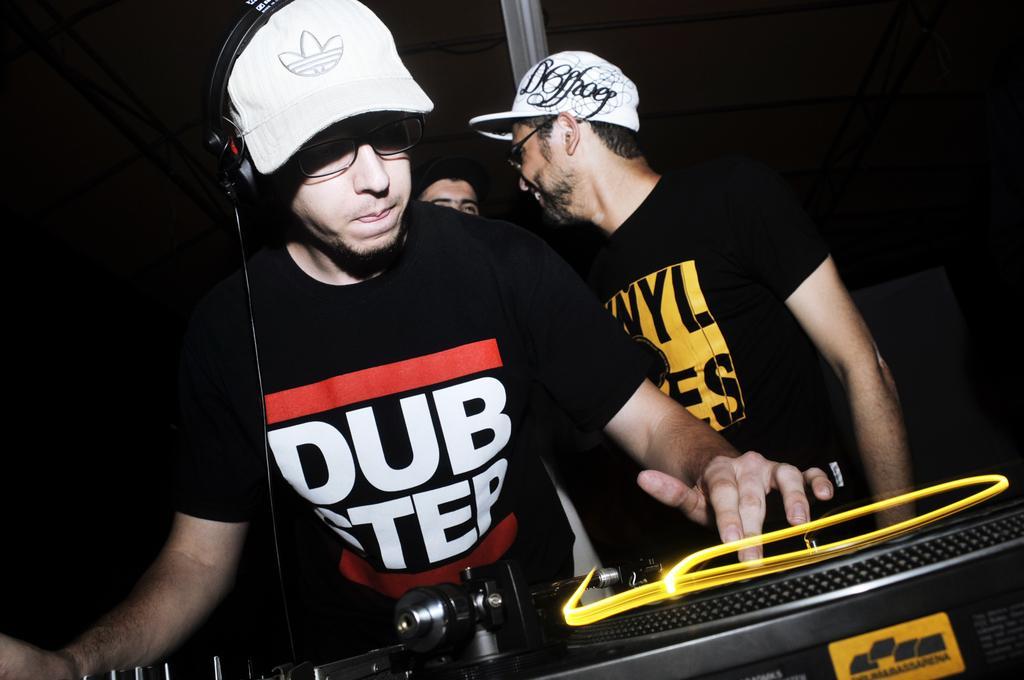Please provide a concise description of this image. In this image there is a man in the middle who is wearing the black t-shirt and white cap is playing the DJ. In the background there are two other persons who are standing. 